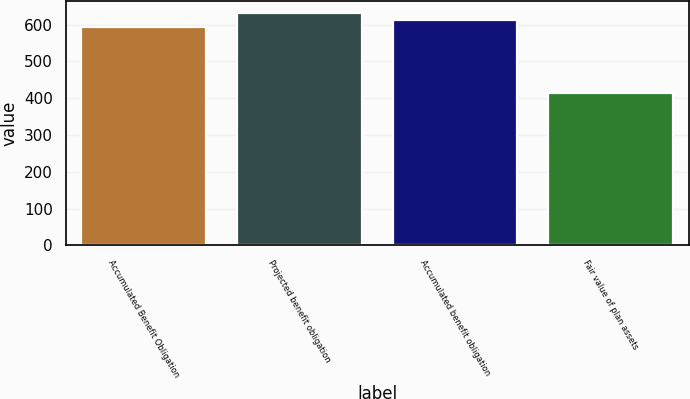Convert chart to OTSL. <chart><loc_0><loc_0><loc_500><loc_500><bar_chart><fcel>Accumulated Benefit Obligation<fcel>Projected benefit obligation<fcel>Accumulated benefit obligation<fcel>Fair value of plan assets<nl><fcel>592<fcel>631<fcel>611.5<fcel>413<nl></chart> 